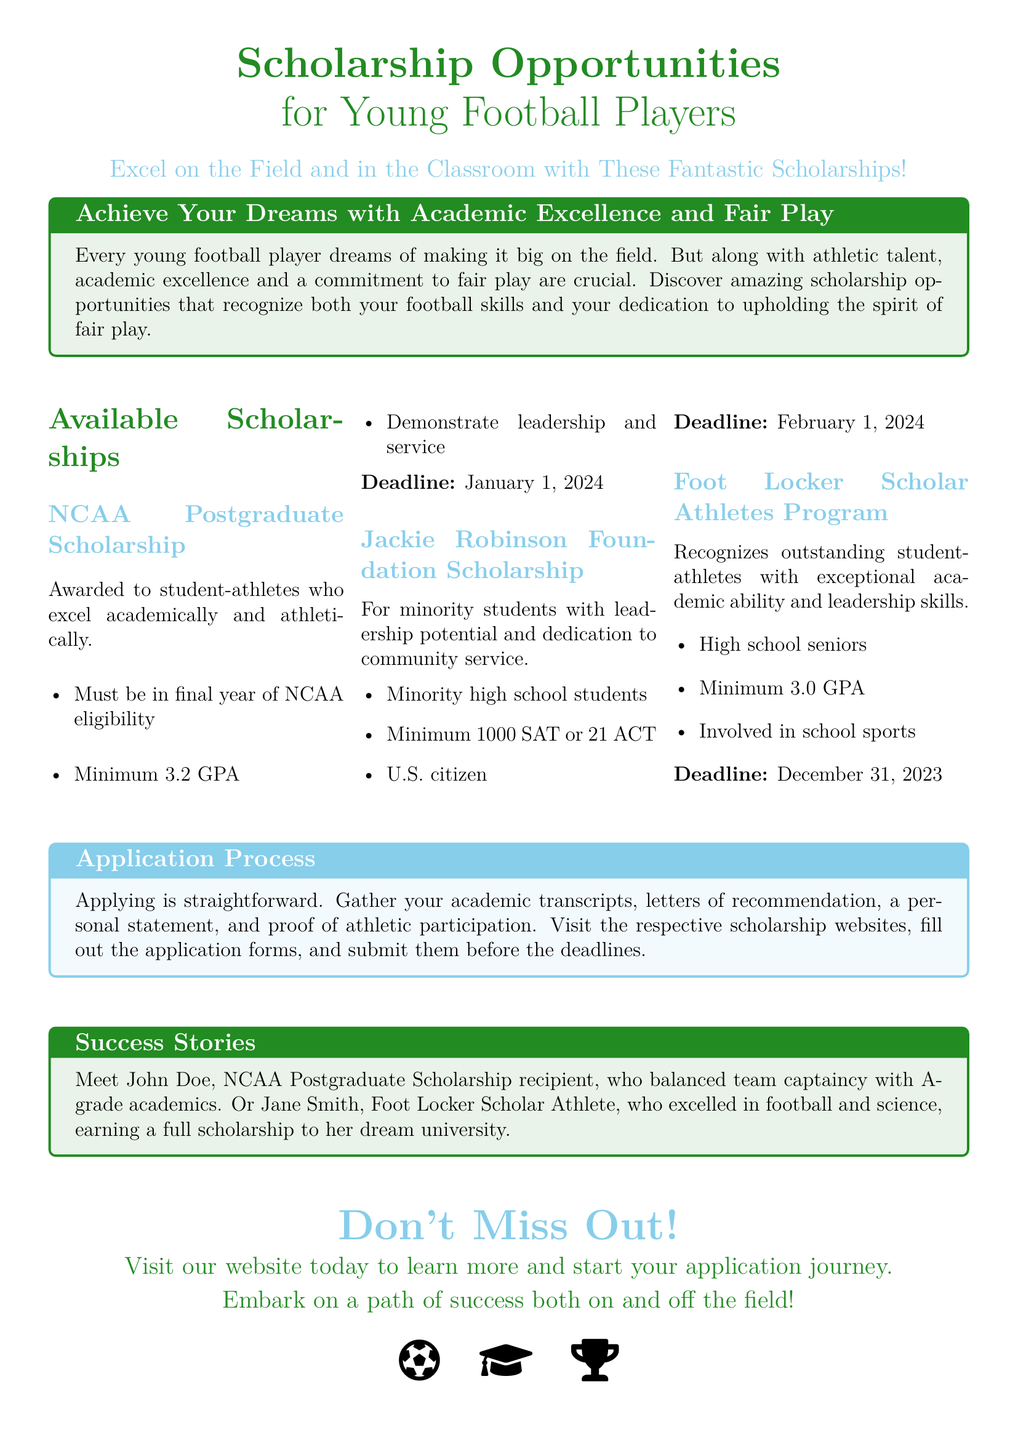What is the title of the ad? The title of the ad is prominently displayed at the top and indicates the main focus of the advertisement.
Answer: Scholarship Opportunities What is the deadline for the NCAA Postgraduate Scholarship? The document specifies the deadline for this particular scholarship under the available scholarships section.
Answer: January 1, 2024 Who can apply for the Jackie Robinson Foundation Scholarship? The eligibility criteria for this scholarship include specific requirements that are mentioned in the document.
Answer: Minority high school students What is the minimum GPA required for the Foot Locker Scholar Athletes Program? The document includes the required GPA for this scholarship in the details provided.
Answer: 3.0 GPA What does the application process consist of? The document outlines the necessary steps to apply for the scholarships.
Answer: Academic transcripts, letters of recommendation, personal statement, proof of athletic participation What do the success stories in the ad aim to illustrate? The success stories highlight the achievements of scholarship recipients as examples of what can be accomplished.
Answer: Balance between academics and athletics What is included in the call to action at the end of the advertisement? The final section urges readers to take specific action related to the scholarships.
Answer: Visit our website today How many scholarships are mentioned in the ad? The number of scholarships listed in the document can be counted directly from the available scholarships section.
Answer: Three 